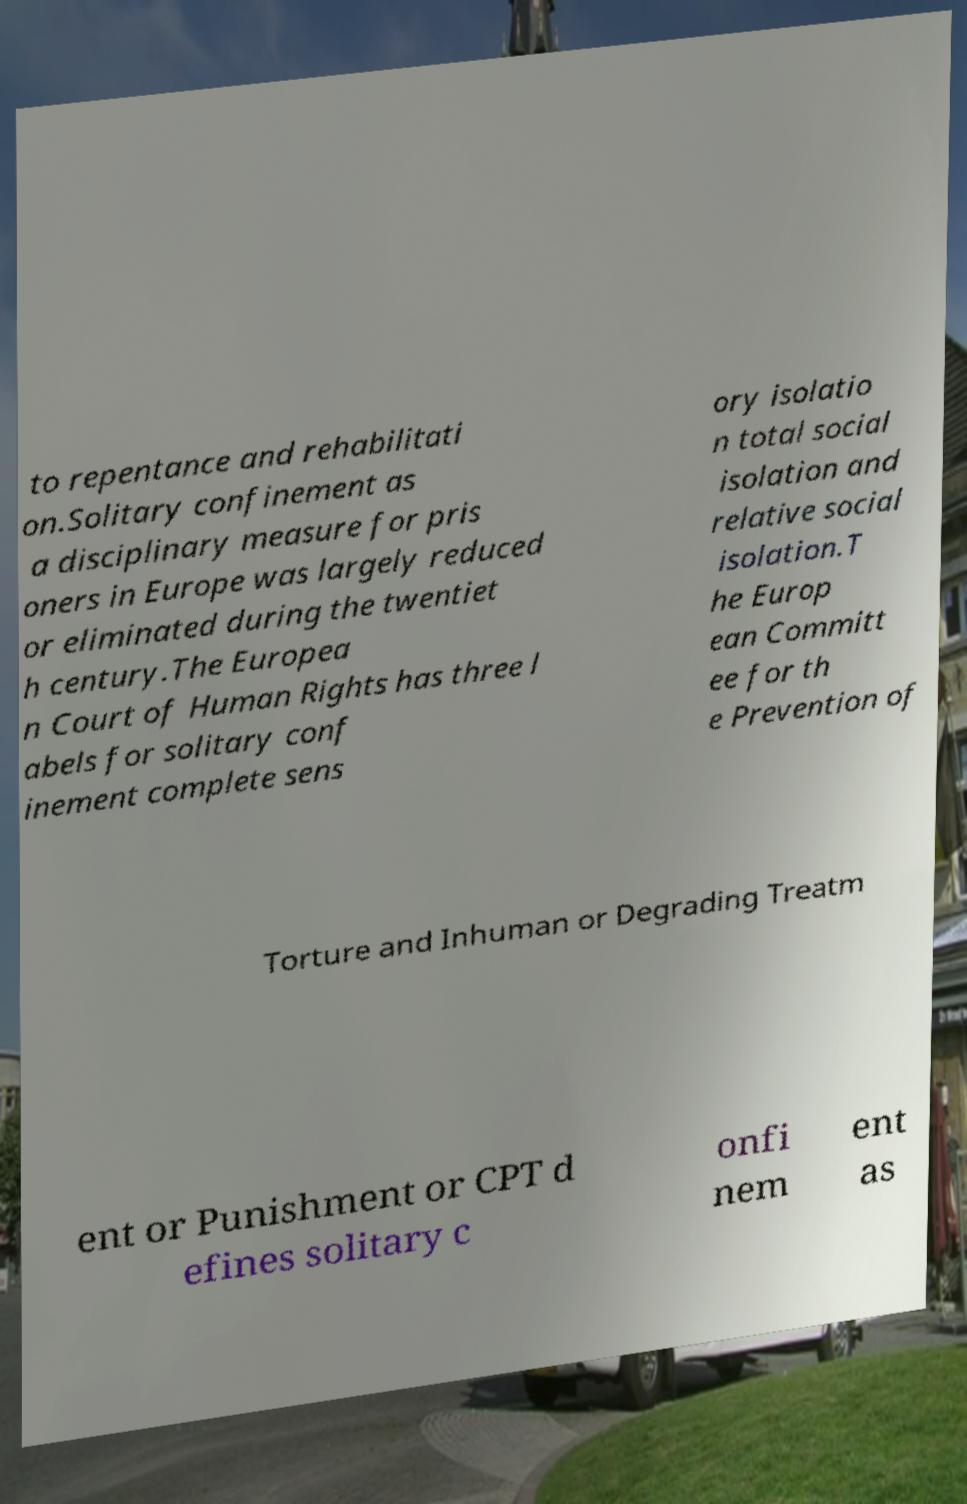There's text embedded in this image that I need extracted. Can you transcribe it verbatim? to repentance and rehabilitati on.Solitary confinement as a disciplinary measure for pris oners in Europe was largely reduced or eliminated during the twentiet h century.The Europea n Court of Human Rights has three l abels for solitary conf inement complete sens ory isolatio n total social isolation and relative social isolation.T he Europ ean Committ ee for th e Prevention of Torture and Inhuman or Degrading Treatm ent or Punishment or CPT d efines solitary c onfi nem ent as 